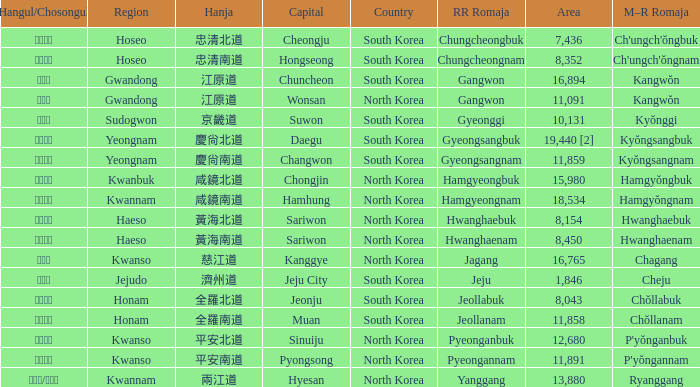Can you give me this table as a dict? {'header': ['Hangul/Chosongul', 'Region', 'Hanja', 'Capital', 'Country', 'RR Romaja', 'Area', 'M–R Romaja'], 'rows': [['충청북도', 'Hoseo', '忠清北道', 'Cheongju', 'South Korea', 'Chungcheongbuk', '7,436', "Ch'ungch'ŏngbuk"], ['충청남도', 'Hoseo', '忠清南道', 'Hongseong', 'South Korea', 'Chungcheongnam', '8,352', "Ch'ungch'ŏngnam"], ['강원도', 'Gwandong', '江原道', 'Chuncheon', 'South Korea', 'Gangwon', '16,894', 'Kangwŏn'], ['강원도', 'Gwandong', '江原道', 'Wonsan', 'North Korea', 'Gangwon', '11,091', 'Kangwŏn'], ['경기도', 'Sudogwon', '京畿道', 'Suwon', 'South Korea', 'Gyeonggi', '10,131', 'Kyŏnggi'], ['경상북도', 'Yeongnam', '慶尙北道', 'Daegu', 'South Korea', 'Gyeongsangbuk', '19,440 [2]', 'Kyŏngsangbuk'], ['경상남도', 'Yeongnam', '慶尙南道', 'Changwon', 'South Korea', 'Gyeongsangnam', '11,859', 'Kyŏngsangnam'], ['함경북도', 'Kwanbuk', '咸鏡北道', 'Chongjin', 'North Korea', 'Hamgyeongbuk', '15,980', 'Hamgyŏngbuk'], ['함경남도', 'Kwannam', '咸鏡南道', 'Hamhung', 'North Korea', 'Hamgyeongnam', '18,534', 'Hamgyŏngnam'], ['황해북도', 'Haeso', '黃海北道', 'Sariwon', 'North Korea', 'Hwanghaebuk', '8,154', 'Hwanghaebuk'], ['황해남도', 'Haeso', '黃海南道', 'Sariwon', 'North Korea', 'Hwanghaenam', '8,450', 'Hwanghaenam'], ['자강도', 'Kwanso', '慈江道', 'Kanggye', 'North Korea', 'Jagang', '16,765', 'Chagang'], ['제주도', 'Jejudo', '濟州道', 'Jeju City', 'South Korea', 'Jeju', '1,846', 'Cheju'], ['전라북도', 'Honam', '全羅北道', 'Jeonju', 'South Korea', 'Jeollabuk', '8,043', 'Chŏllabuk'], ['전라남도', 'Honam', '全羅南道', 'Muan', 'South Korea', 'Jeollanam', '11,858', 'Chŏllanam'], ['평안북도', 'Kwanso', '平安北道', 'Sinuiju', 'North Korea', 'Pyeonganbuk', '12,680', "P'yŏnganbuk"], ['평안남도', 'Kwanso', '平安南道', 'Pyongsong', 'North Korea', 'Pyeongannam', '11,891', "P'yŏngannam"], ['량강도/양강도', 'Kwannam', '兩江道', 'Hyesan', 'North Korea', 'Yanggang', '13,880', 'Ryanggang']]} Which country has a city with a Hanja of 平安北道? North Korea. 